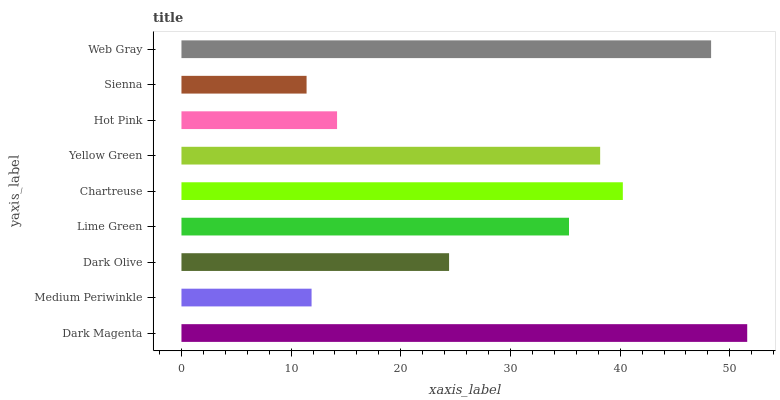Is Sienna the minimum?
Answer yes or no. Yes. Is Dark Magenta the maximum?
Answer yes or no. Yes. Is Medium Periwinkle the minimum?
Answer yes or no. No. Is Medium Periwinkle the maximum?
Answer yes or no. No. Is Dark Magenta greater than Medium Periwinkle?
Answer yes or no. Yes. Is Medium Periwinkle less than Dark Magenta?
Answer yes or no. Yes. Is Medium Periwinkle greater than Dark Magenta?
Answer yes or no. No. Is Dark Magenta less than Medium Periwinkle?
Answer yes or no. No. Is Lime Green the high median?
Answer yes or no. Yes. Is Lime Green the low median?
Answer yes or no. Yes. Is Medium Periwinkle the high median?
Answer yes or no. No. Is Sienna the low median?
Answer yes or no. No. 